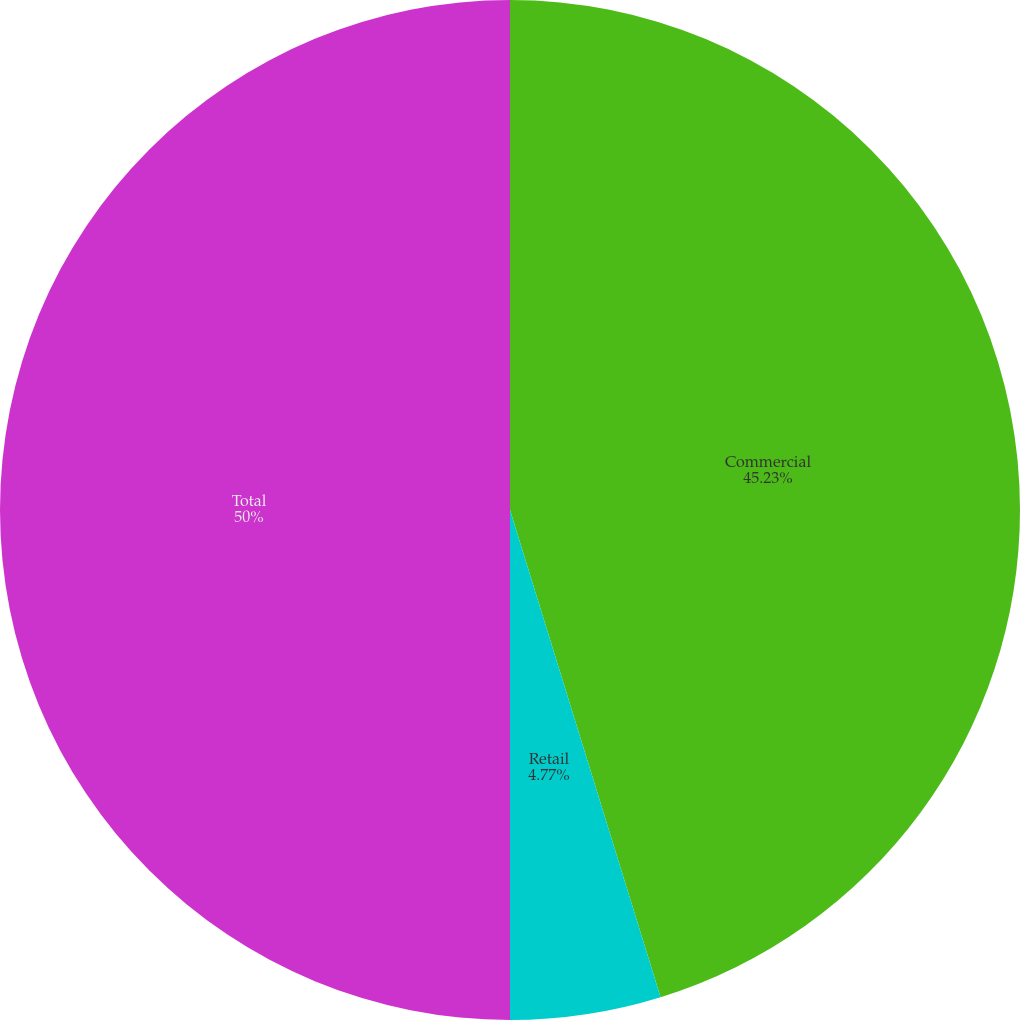Convert chart. <chart><loc_0><loc_0><loc_500><loc_500><pie_chart><fcel>Commercial<fcel>Retail<fcel>Total<nl><fcel>45.23%<fcel>4.77%<fcel>50.0%<nl></chart> 